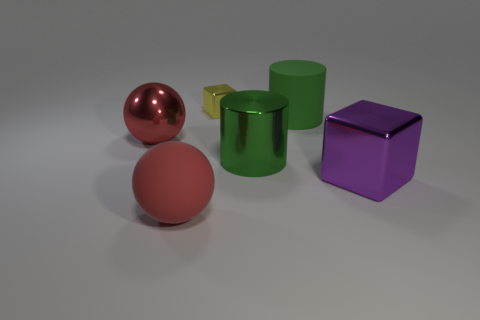Add 1 large shiny blocks. How many objects exist? 7 Subtract all cubes. How many objects are left? 4 Subtract 2 red balls. How many objects are left? 4 Subtract all small blocks. Subtract all rubber things. How many objects are left? 3 Add 3 matte balls. How many matte balls are left? 4 Add 4 big rubber cylinders. How many big rubber cylinders exist? 5 